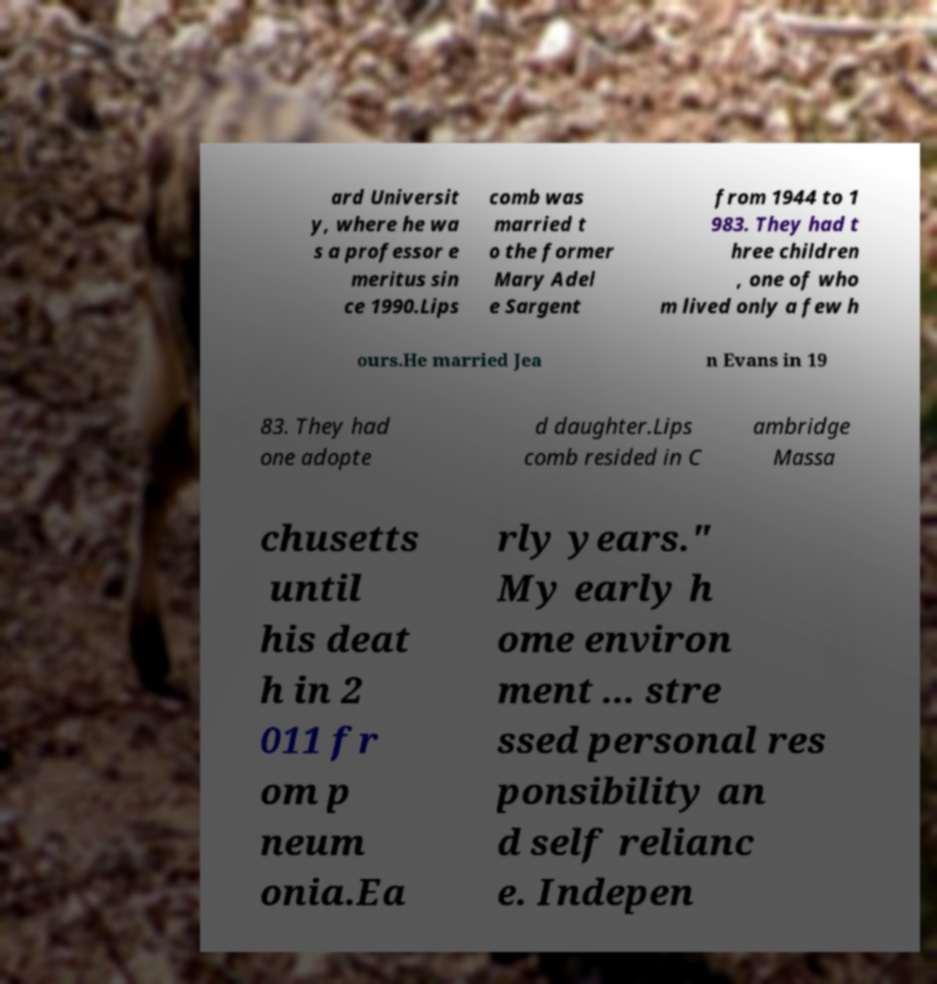What messages or text are displayed in this image? I need them in a readable, typed format. ard Universit y, where he wa s a professor e meritus sin ce 1990.Lips comb was married t o the former Mary Adel e Sargent from 1944 to 1 983. They had t hree children , one of who m lived only a few h ours.He married Jea n Evans in 19 83. They had one adopte d daughter.Lips comb resided in C ambridge Massa chusetts until his deat h in 2 011 fr om p neum onia.Ea rly years." My early h ome environ ment ... stre ssed personal res ponsibility an d self relianc e. Indepen 